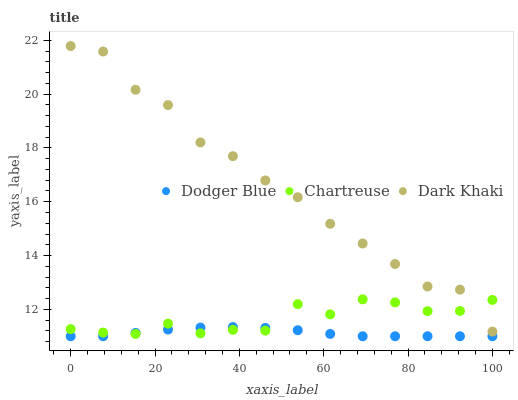Does Dodger Blue have the minimum area under the curve?
Answer yes or no. Yes. Does Dark Khaki have the maximum area under the curve?
Answer yes or no. Yes. Does Chartreuse have the minimum area under the curve?
Answer yes or no. No. Does Chartreuse have the maximum area under the curve?
Answer yes or no. No. Is Dodger Blue the smoothest?
Answer yes or no. Yes. Is Dark Khaki the roughest?
Answer yes or no. Yes. Is Chartreuse the smoothest?
Answer yes or no. No. Is Chartreuse the roughest?
Answer yes or no. No. Does Dodger Blue have the lowest value?
Answer yes or no. Yes. Does Chartreuse have the lowest value?
Answer yes or no. No. Does Dark Khaki have the highest value?
Answer yes or no. Yes. Does Chartreuse have the highest value?
Answer yes or no. No. Is Dodger Blue less than Dark Khaki?
Answer yes or no. Yes. Is Dark Khaki greater than Dodger Blue?
Answer yes or no. Yes. Does Dodger Blue intersect Chartreuse?
Answer yes or no. Yes. Is Dodger Blue less than Chartreuse?
Answer yes or no. No. Is Dodger Blue greater than Chartreuse?
Answer yes or no. No. Does Dodger Blue intersect Dark Khaki?
Answer yes or no. No. 